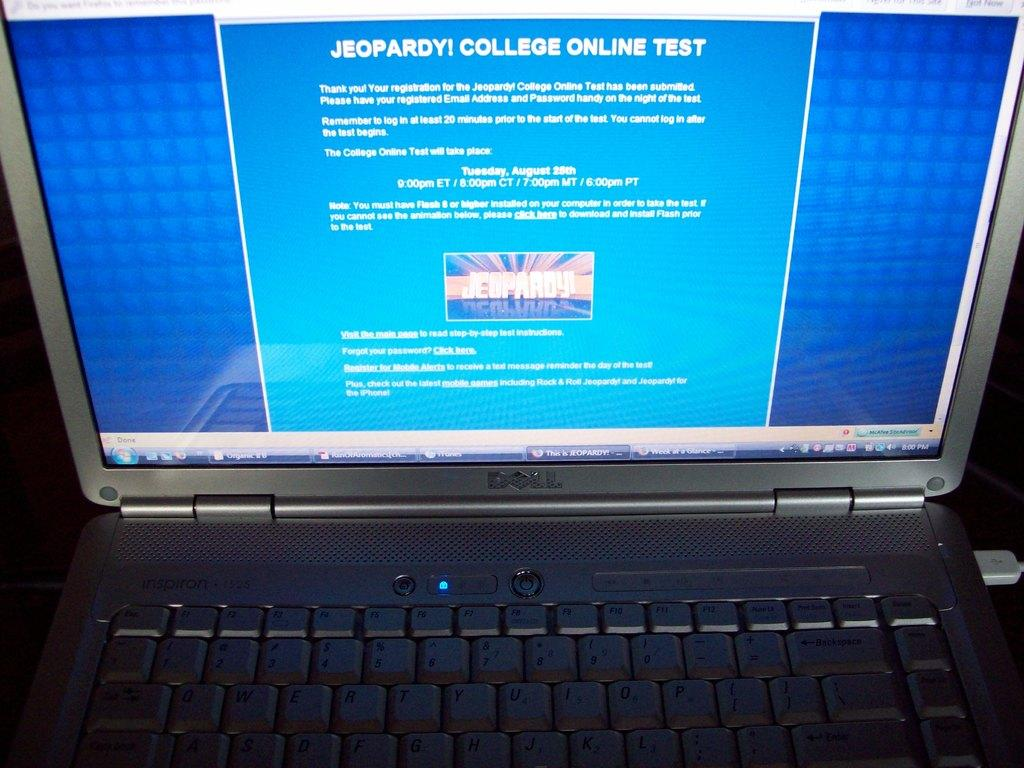<image>
Relay a brief, clear account of the picture shown. A dell laptop displaying  jeopardy college online test 